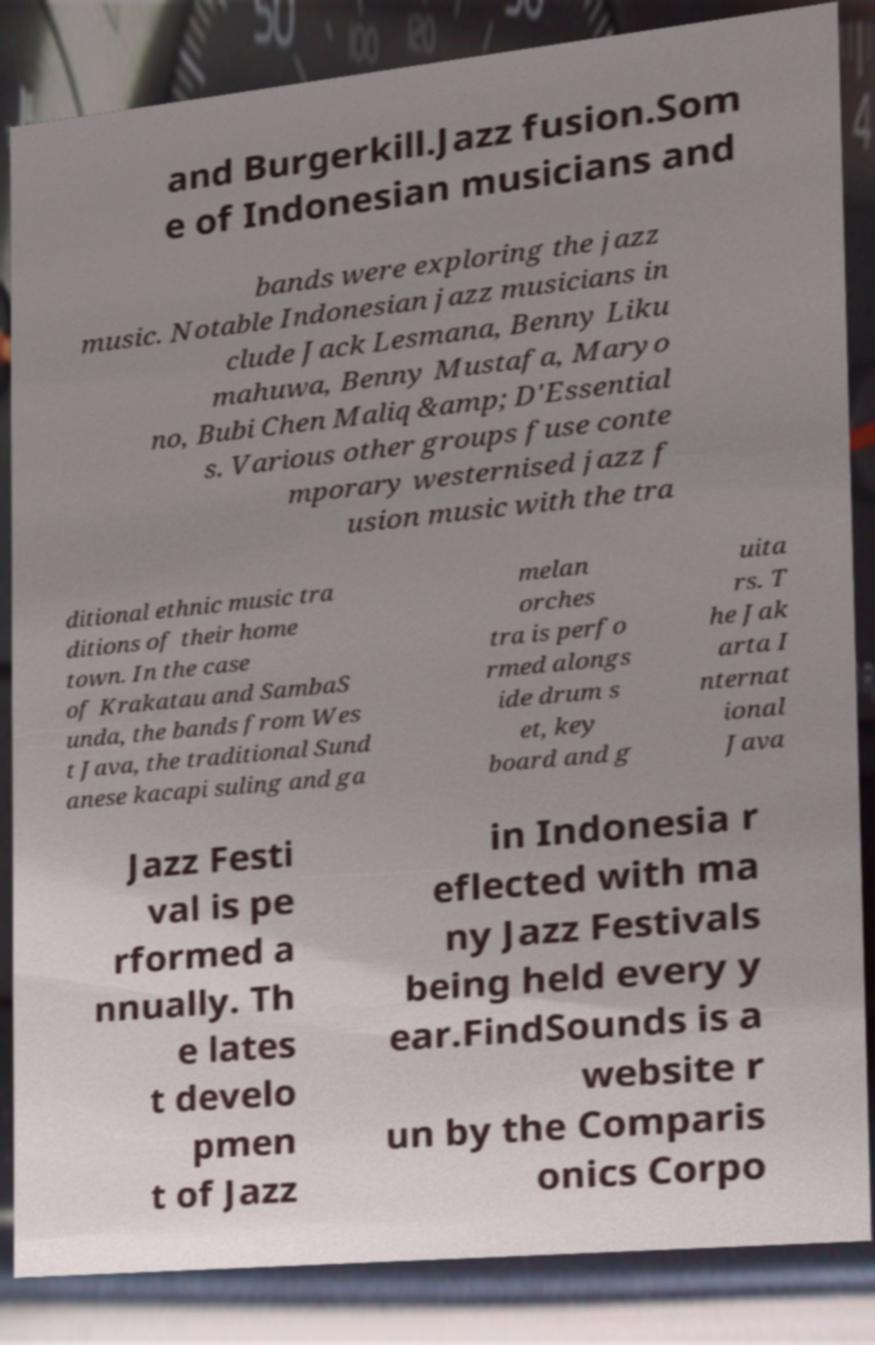Could you extract and type out the text from this image? and Burgerkill.Jazz fusion.Som e of Indonesian musicians and bands were exploring the jazz music. Notable Indonesian jazz musicians in clude Jack Lesmana, Benny Liku mahuwa, Benny Mustafa, Maryo no, Bubi Chen Maliq &amp; D'Essential s. Various other groups fuse conte mporary westernised jazz f usion music with the tra ditional ethnic music tra ditions of their home town. In the case of Krakatau and SambaS unda, the bands from Wes t Java, the traditional Sund anese kacapi suling and ga melan orches tra is perfo rmed alongs ide drum s et, key board and g uita rs. T he Jak arta I nternat ional Java Jazz Festi val is pe rformed a nnually. Th e lates t develo pmen t of Jazz in Indonesia r eflected with ma ny Jazz Festivals being held every y ear.FindSounds is a website r un by the Comparis onics Corpo 